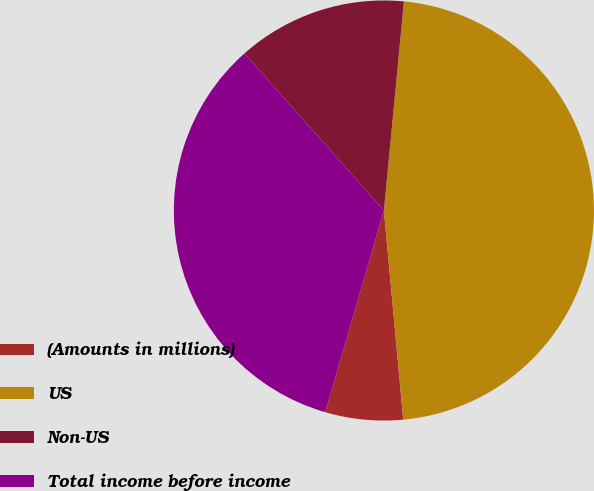<chart> <loc_0><loc_0><loc_500><loc_500><pie_chart><fcel>(Amounts in millions)<fcel>US<fcel>Non-US<fcel>Total income before income<nl><fcel>5.98%<fcel>47.01%<fcel>13.07%<fcel>33.94%<nl></chart> 